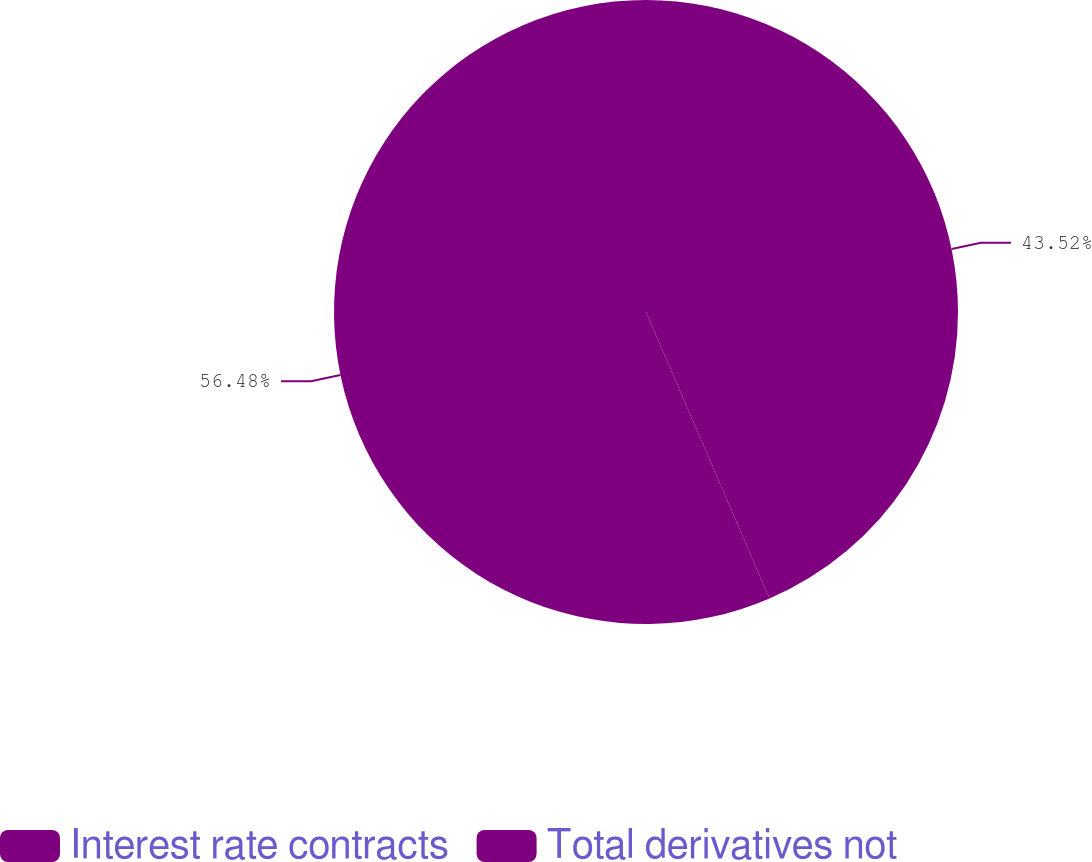Convert chart to OTSL. <chart><loc_0><loc_0><loc_500><loc_500><pie_chart><fcel>Interest rate contracts<fcel>Total derivatives not<nl><fcel>43.52%<fcel>56.48%<nl></chart> 